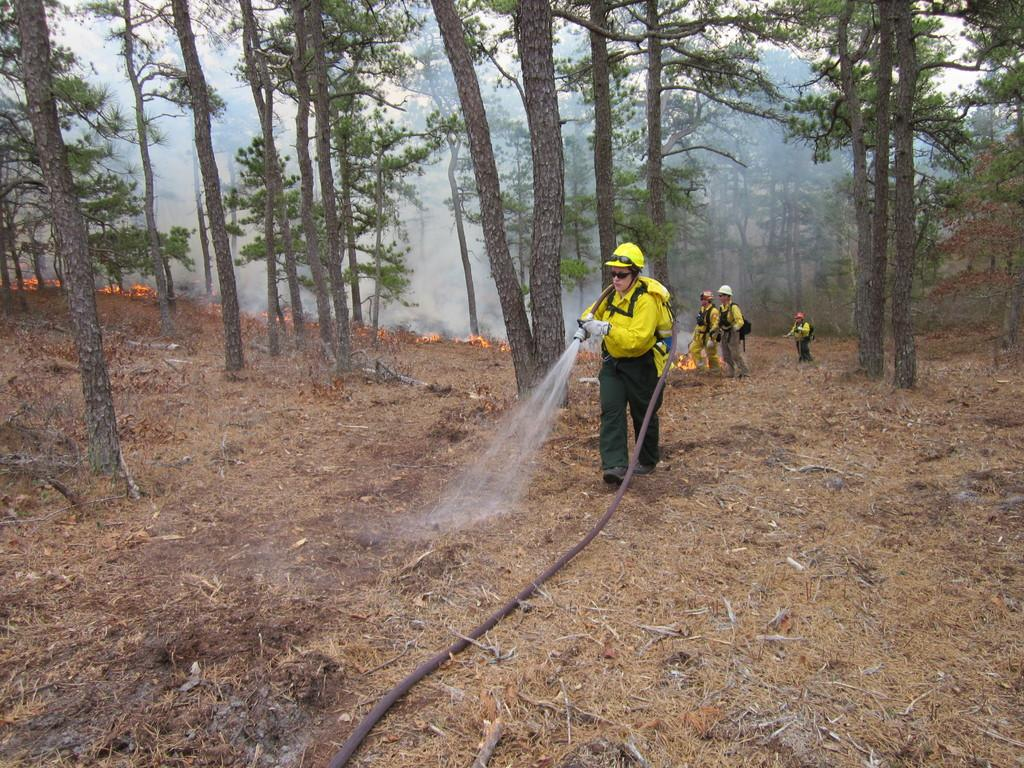What is the person in the image wearing? The person is wearing a yellow dress in the image. What is the person holding in the image? The person is holding a water pipe in the image. Are there any other people visible in the image? Yes, there are other persons standing behind the person with the water pipe. What can be seen in the background of the image? There are trees in the background of the image. What type of patch is sewn onto the dress of the person in the image? There is no mention of a patch on the dress in the image, so we cannot answer this question. 